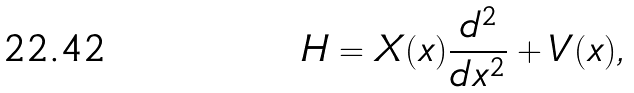<formula> <loc_0><loc_0><loc_500><loc_500>H = X ( x ) \frac { d ^ { 2 } } { d x ^ { 2 } } + V ( x ) ,</formula> 